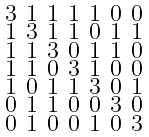Convert formula to latex. <formula><loc_0><loc_0><loc_500><loc_500>\begin{smallmatrix} 3 & 1 & 1 & 1 & 1 & 0 & 0 \\ 1 & 3 & 1 & 1 & 0 & 1 & 1 \\ 1 & 1 & 3 & 0 & 1 & 1 & 0 \\ 1 & 1 & 0 & 3 & 1 & 0 & 0 \\ 1 & 0 & 1 & 1 & 3 & 0 & 1 \\ 0 & 1 & 1 & 0 & 0 & 3 & 0 \\ 0 & 1 & 0 & 0 & 1 & 0 & 3 \end{smallmatrix}</formula> 